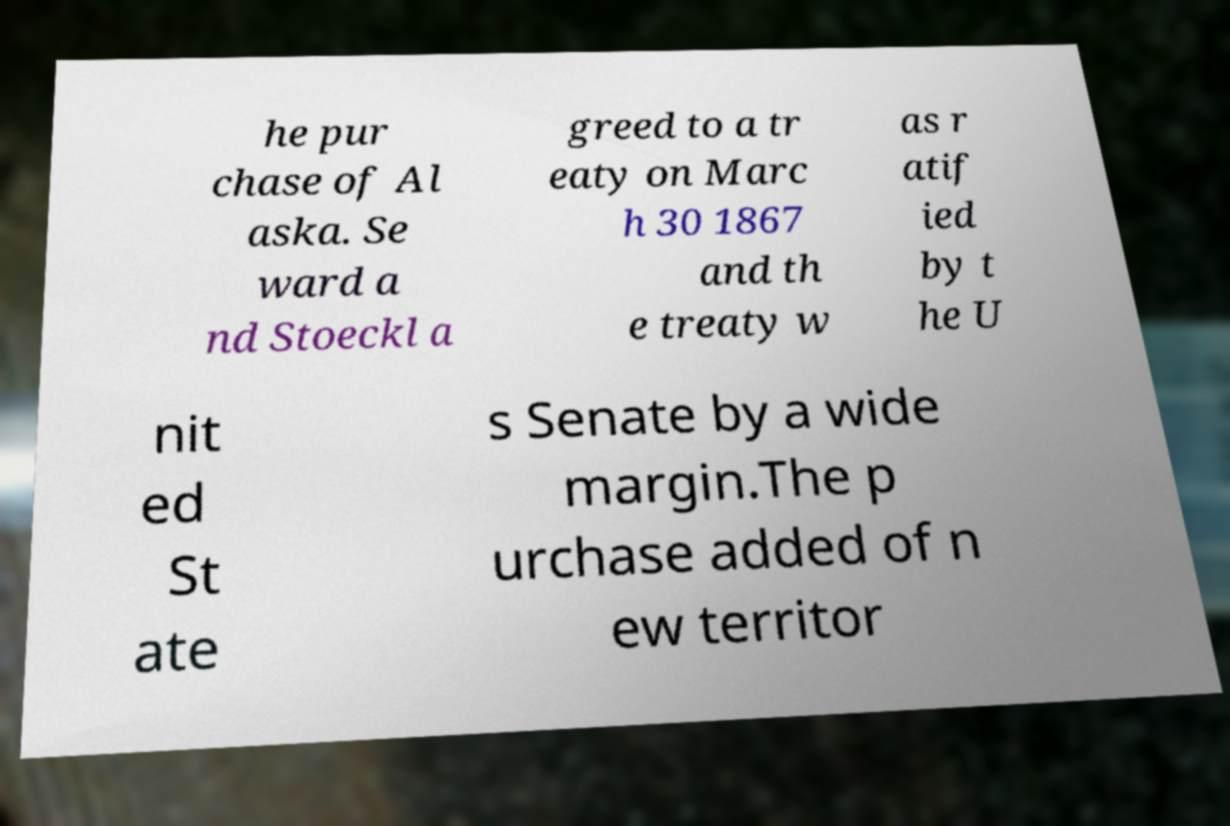I need the written content from this picture converted into text. Can you do that? he pur chase of Al aska. Se ward a nd Stoeckl a greed to a tr eaty on Marc h 30 1867 and th e treaty w as r atif ied by t he U nit ed St ate s Senate by a wide margin.The p urchase added of n ew territor 